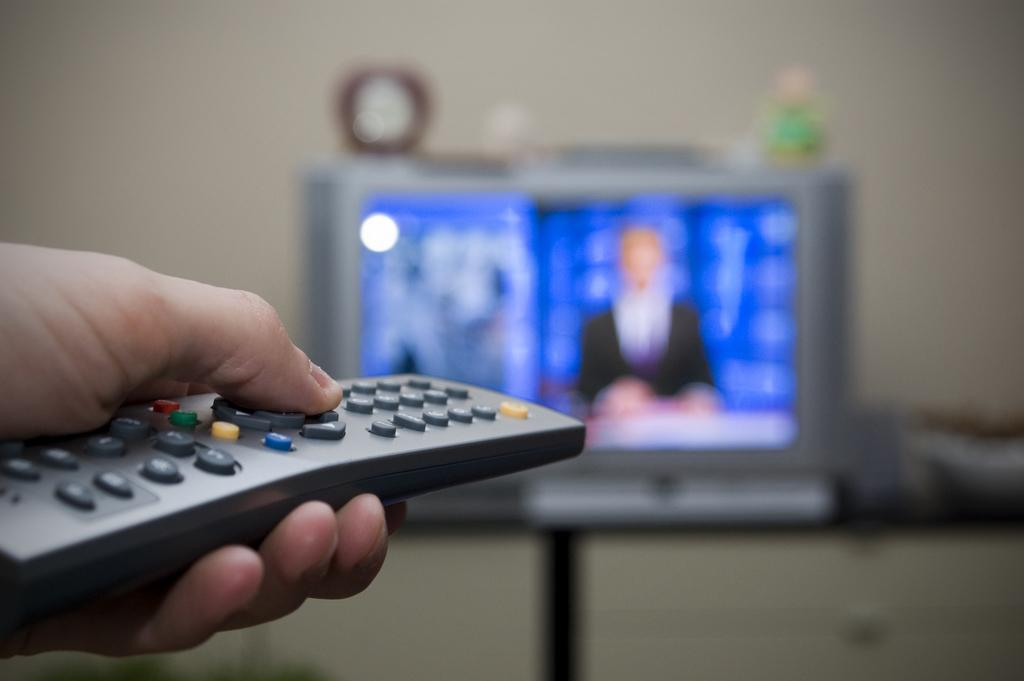What is the person holding in the image? The hand of a person is holding a remote in the image. What is the main object on the table in the image? There is a TV on a table in the image. What is placed on top of the TV in the image? There are toys on the TV in the image. What can be seen behind the TV in the image? There is a wall visible in the image. How would you describe the background of the image? The background of the image is blurred. What type of coat is the person wearing while discussing the guitar in the image? There is no person wearing a coat or discussing a guitar in the image. 